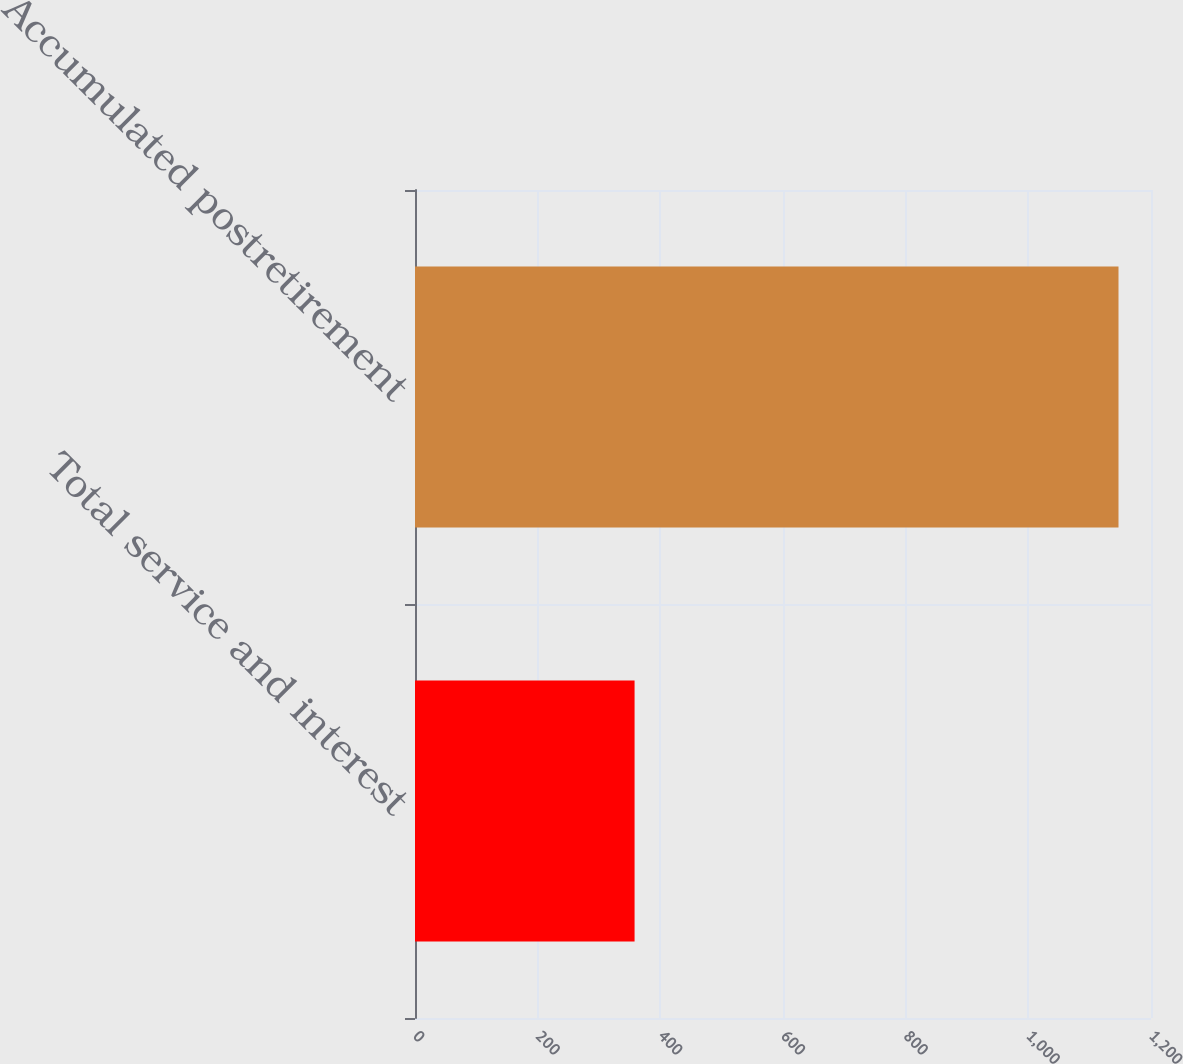<chart> <loc_0><loc_0><loc_500><loc_500><bar_chart><fcel>Total service and interest<fcel>Accumulated postretirement<nl><fcel>358<fcel>1147<nl></chart> 